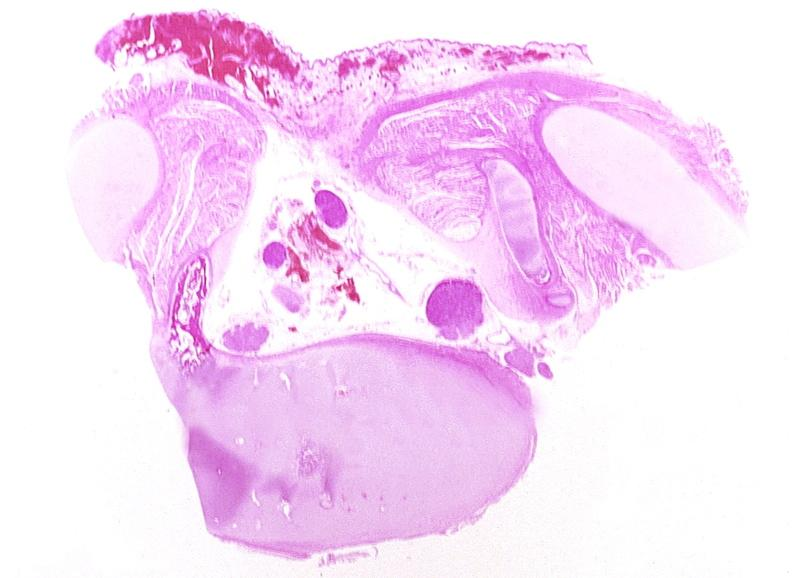does malignant histiocytosis show neural tube defect, meningomyelocele?
Answer the question using a single word or phrase. No 